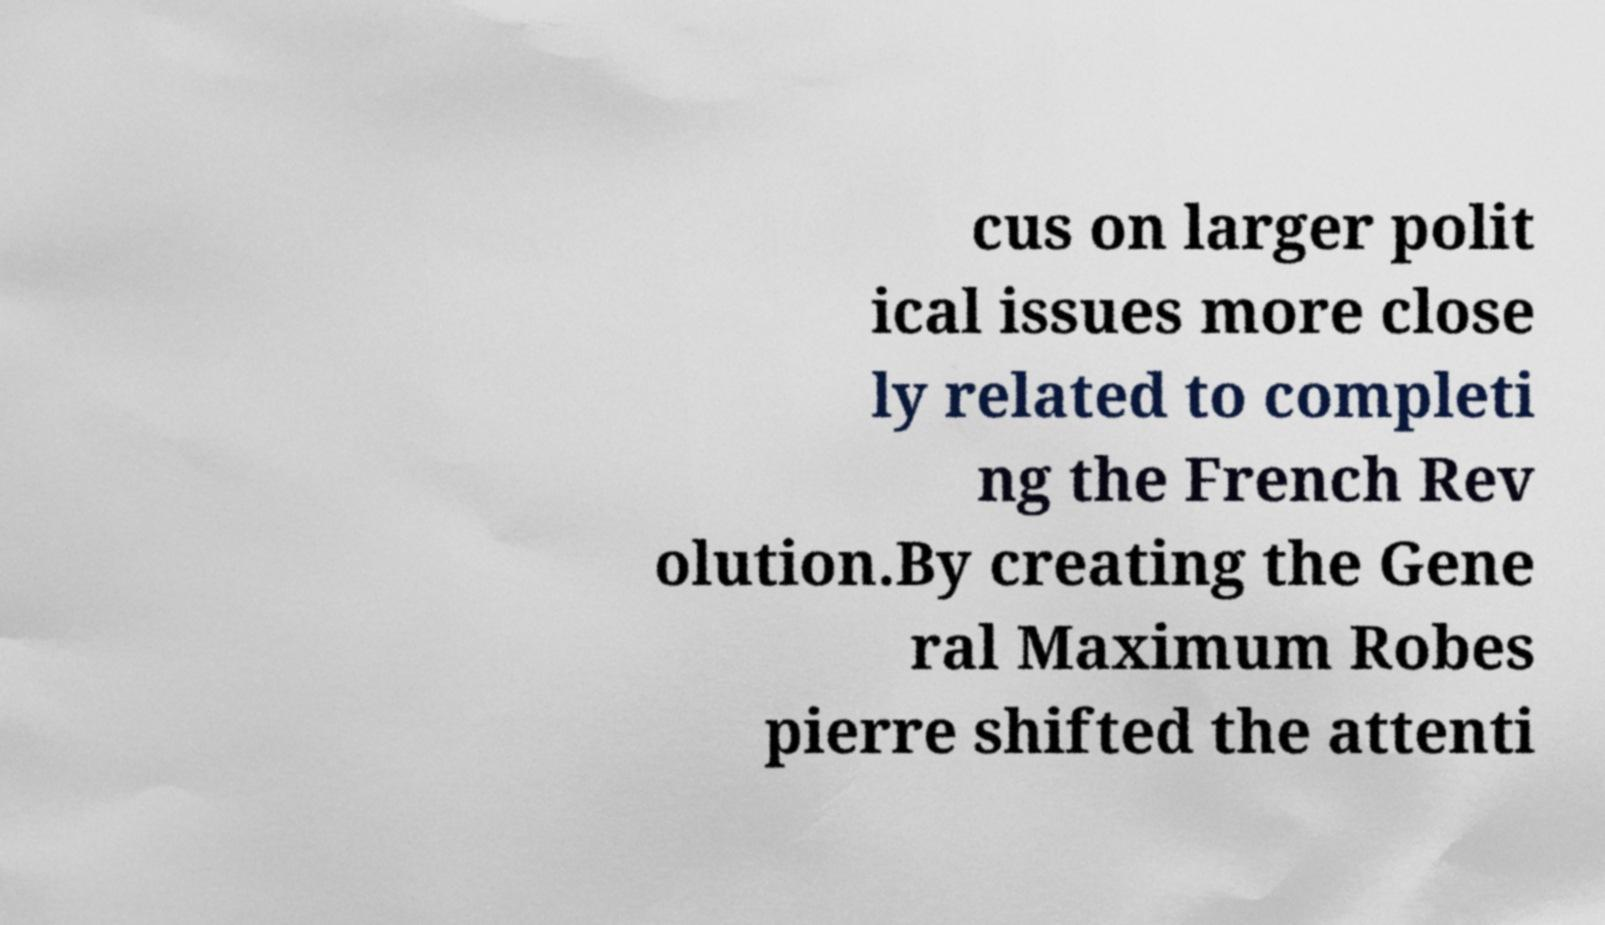There's text embedded in this image that I need extracted. Can you transcribe it verbatim? cus on larger polit ical issues more close ly related to completi ng the French Rev olution.By creating the Gene ral Maximum Robes pierre shifted the attenti 